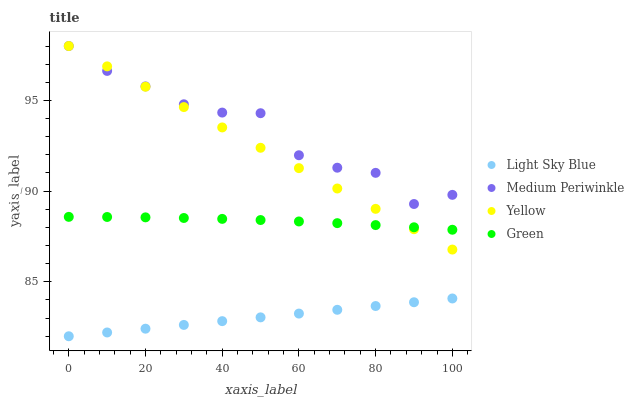Does Light Sky Blue have the minimum area under the curve?
Answer yes or no. Yes. Does Medium Periwinkle have the maximum area under the curve?
Answer yes or no. Yes. Does Medium Periwinkle have the minimum area under the curve?
Answer yes or no. No. Does Light Sky Blue have the maximum area under the curve?
Answer yes or no. No. Is Light Sky Blue the smoothest?
Answer yes or no. Yes. Is Medium Periwinkle the roughest?
Answer yes or no. Yes. Is Medium Periwinkle the smoothest?
Answer yes or no. No. Is Light Sky Blue the roughest?
Answer yes or no. No. Does Light Sky Blue have the lowest value?
Answer yes or no. Yes. Does Medium Periwinkle have the lowest value?
Answer yes or no. No. Does Yellow have the highest value?
Answer yes or no. Yes. Does Light Sky Blue have the highest value?
Answer yes or no. No. Is Light Sky Blue less than Medium Periwinkle?
Answer yes or no. Yes. Is Green greater than Light Sky Blue?
Answer yes or no. Yes. Does Medium Periwinkle intersect Yellow?
Answer yes or no. Yes. Is Medium Periwinkle less than Yellow?
Answer yes or no. No. Is Medium Periwinkle greater than Yellow?
Answer yes or no. No. Does Light Sky Blue intersect Medium Periwinkle?
Answer yes or no. No. 